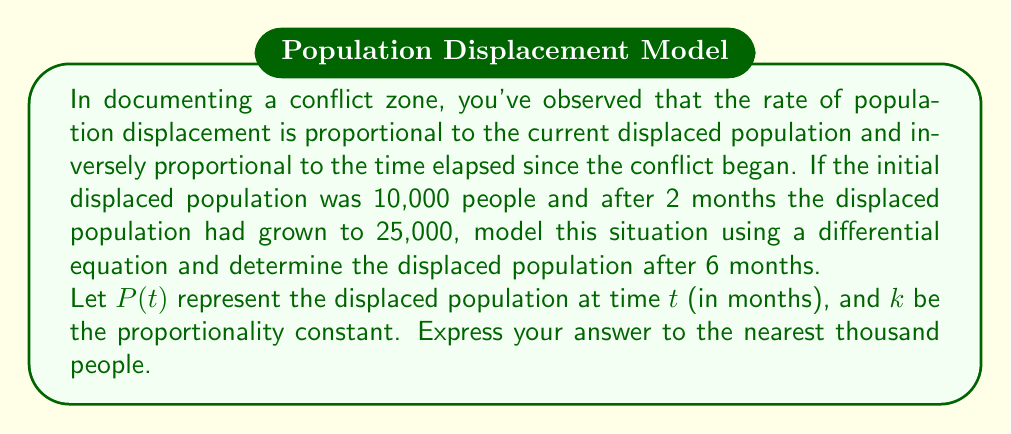Can you solve this math problem? Let's approach this step-by-step:

1) Based on the given information, we can model this situation with the differential equation:

   $$\frac{dP}{dt} = \frac{kP}{t}$$

   where $k$ is a constant we need to determine.

2) This is a separable differential equation. Let's separate and integrate:

   $$\int \frac{dP}{P} = \int \frac{k}{t} dt$$

3) Integrating both sides:

   $$\ln|P| = k\ln|t| + C$$

4) Exponentiating both sides:

   $$P = At^k$$

   where $A = e^C$ is a constant we need to determine.

5) We're given two conditions:
   At $t = 0$, $P = 10,000$
   At $t = 2$, $P = 25,000$

6) Using the first condition:

   $10,000 = A(0)^k$ is undefined, so we can't use this directly.

7) Using the second condition:

   $25,000 = A(2)^k$

8) We need another equation. Let's use the original differential equation at $t = 2$:

   $$\frac{dP}{dt}\bigg|_{t=2} = \frac{k(25,000)}{2}$$

9) We can also find this derivative from our general solution:

   $$\frac{dP}{dt} = Akt^{k-1}$$

   At $t = 2$: $\frac{dP}{dt}\bigg|_{t=2} = Ak2^{k-1}$

10) Equating these:

    $$Ak2^{k-1} = \frac{k(25,000)}{2}$$

11) Dividing the equation from step 7 by this equation:

    $$\frac{25,000}{Ak2^{k-1}} = \frac{2}{k}$$

    $$2^k = 2$$

    $$k = 1$$

12) Now we can find $A$:

    $25,000 = A(2)^1$
    $A = 12,500$

13) Our final model is:

    $$P = 12,500t$$

14) To find the population after 6 months:

    $$P(6) = 12,500(6) = 75,000$$
Answer: 75,000 people 